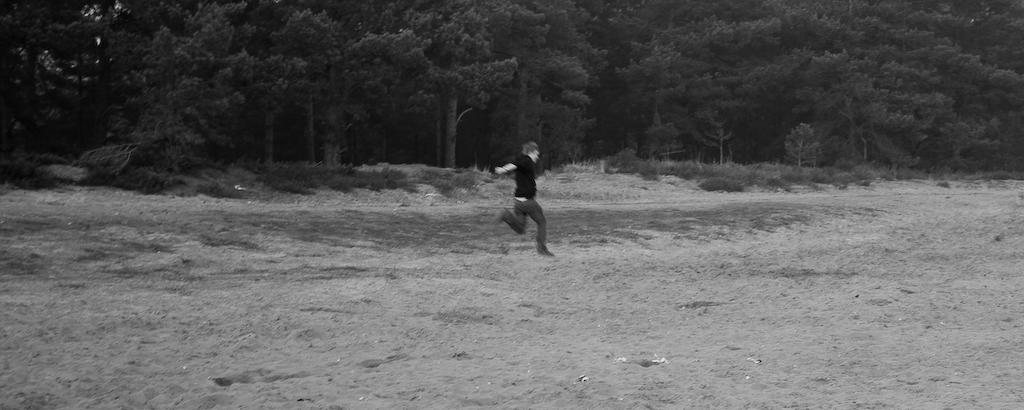What is the primary setting of the image? There is a ground in the image. What is the person in the image doing? There is a person running on the ground. What can be seen in the background of the image? There is a plant and trees in the background of the image. Where is the match being used in the image? There is no match present in the image. Can you see any hydrants in the image? There are no hydrants visible in the image. 